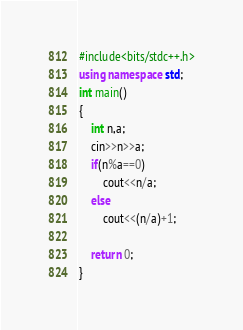<code> <loc_0><loc_0><loc_500><loc_500><_C++_>#include<bits/stdc++.h>
using namespace std;
int main()
{
    int n,a;
    cin>>n>>a;
    if(n%a==0)
        cout<<n/a;
    else
        cout<<(n/a)+1;

    return 0;
}
</code> 